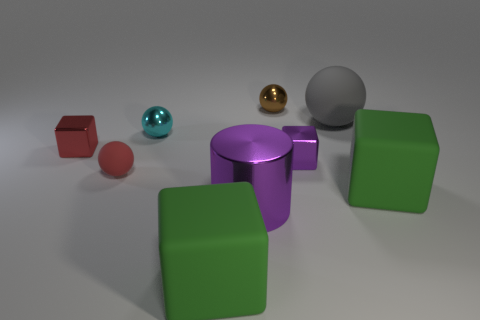There is a object that is behind the rubber object that is behind the cyan thing; what number of tiny things are to the right of it?
Ensure brevity in your answer.  1. There is a cylinder; does it have the same color as the tiny metal cube that is right of the metallic cylinder?
Your response must be concise. Yes. What size is the purple cylinder that is made of the same material as the small purple cube?
Ensure brevity in your answer.  Large. Is the number of shiny things in front of the tiny cyan sphere greater than the number of blue balls?
Ensure brevity in your answer.  Yes. What is the material of the large green cube that is on the right side of the tiny shiny cube to the right of the red rubber sphere that is to the left of the small purple metal thing?
Offer a terse response. Rubber. Do the big gray ball and the purple block behind the cylinder have the same material?
Keep it short and to the point. No. There is a small brown thing that is the same shape as the small cyan metal object; what material is it?
Your answer should be very brief. Metal. Are there more tiny rubber balls that are on the left side of the purple block than small things that are behind the red metal cube?
Your response must be concise. No. There is a cyan object that is made of the same material as the big purple thing; what shape is it?
Offer a terse response. Sphere. What number of other objects are the same shape as the large purple shiny object?
Provide a succinct answer. 0. 